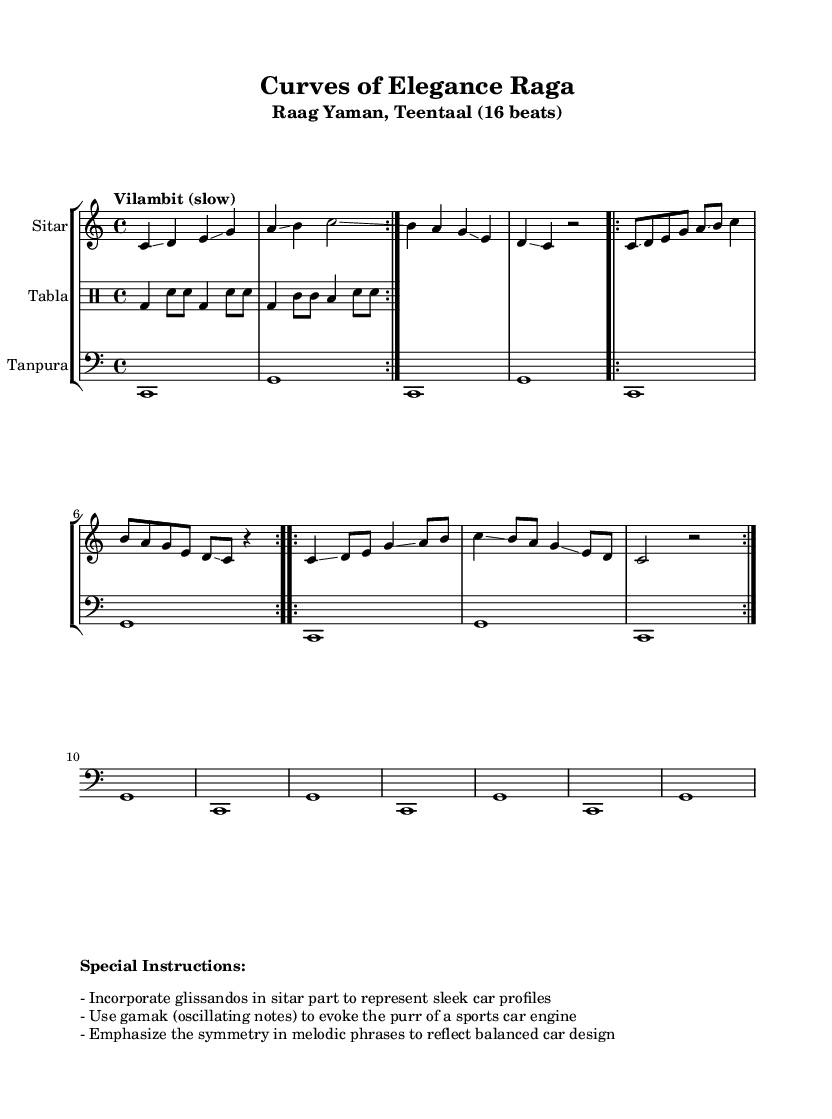What is the key signature of this music? The key signature is C major, which has no sharps or flats.
Answer: C major What is the time signature used in the piece? The time signature is indicated as 4/4 at the beginning of the staff.
Answer: 4/4 What is the tempo marking for this composition? The tempo marking states "Vilambit (slow)," indicating the pace of the piece.
Answer: Vilambit How many beats are in a complete cycle of Teentaal? Teentaal consists of 16 beats in total, organized in groups of 4.
Answer: 16 What technique is indicated to represent the curves of luxury sports cars? The technique indicated is "glissando," which creates a slide effect in the music.
Answer: Glissando What does the term "gamak" signify in this context? "Gamak" refers to the oscillating notes that evoke the purring sound of a sports car engine.
Answer: Gamak What instrument is used for the drone accompaniment in this piece? The instrument used for the drone is the "Tanpura," which provides a continuous sound background.
Answer: Tanpura 